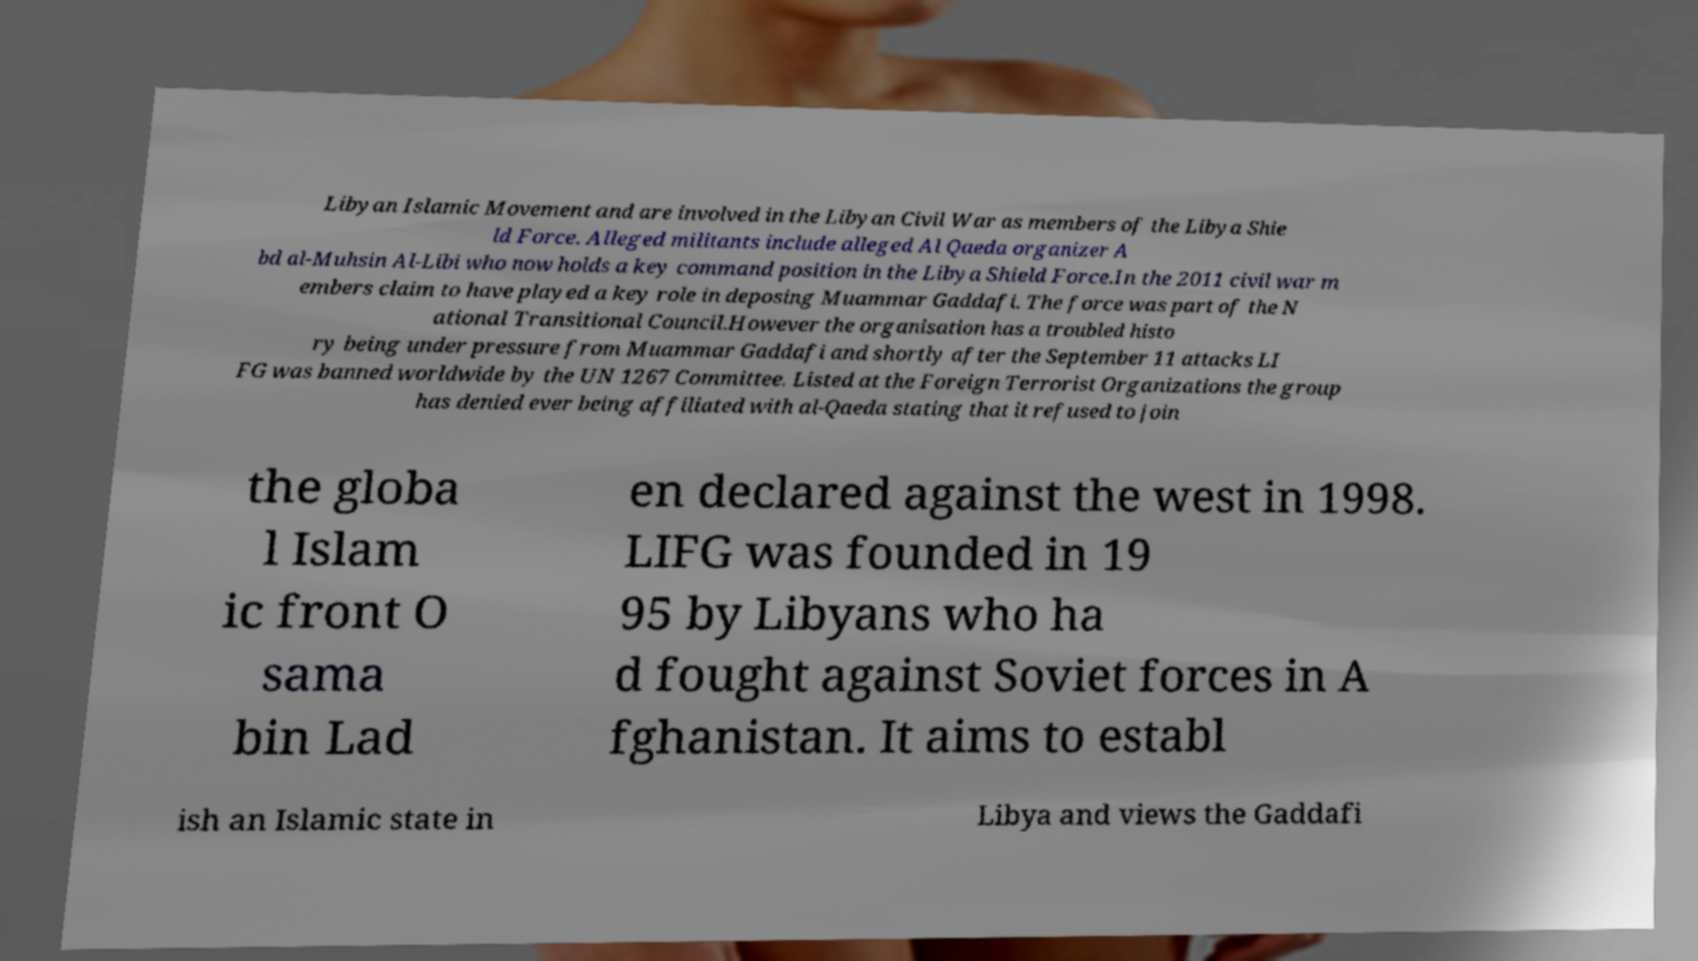Can you read and provide the text displayed in the image?This photo seems to have some interesting text. Can you extract and type it out for me? Libyan Islamic Movement and are involved in the Libyan Civil War as members of the Libya Shie ld Force. Alleged militants include alleged Al Qaeda organizer A bd al-Muhsin Al-Libi who now holds a key command position in the Libya Shield Force.In the 2011 civil war m embers claim to have played a key role in deposing Muammar Gaddafi. The force was part of the N ational Transitional Council.However the organisation has a troubled histo ry being under pressure from Muammar Gaddafi and shortly after the September 11 attacks LI FG was banned worldwide by the UN 1267 Committee. Listed at the Foreign Terrorist Organizations the group has denied ever being affiliated with al-Qaeda stating that it refused to join the globa l Islam ic front O sama bin Lad en declared against the west in 1998. LIFG was founded in 19 95 by Libyans who ha d fought against Soviet forces in A fghanistan. It aims to establ ish an Islamic state in Libya and views the Gaddafi 